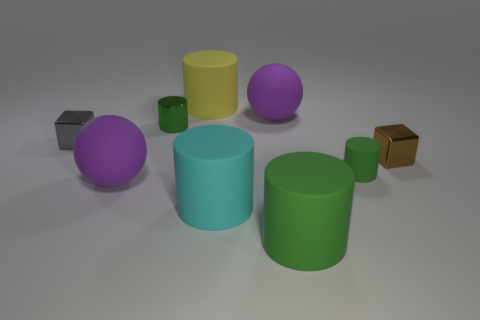There is a matte thing that is the same color as the tiny rubber cylinder; what size is it?
Offer a very short reply. Large. Is there any other thing that is the same shape as the big green matte object?
Provide a short and direct response. Yes. There is a small cylinder that is left of the large purple matte sphere that is behind the gray cube; are there any big purple spheres in front of it?
Keep it short and to the point. Yes. How many big yellow things are the same material as the brown cube?
Ensure brevity in your answer.  0. There is a green matte cylinder that is on the left side of the tiny green rubber cylinder; is its size the same as the shiny block on the right side of the large green matte thing?
Offer a terse response. No. There is a small metallic cube right of the big purple matte object that is in front of the tiny green thing that is behind the small green rubber cylinder; what color is it?
Make the answer very short. Brown. Is there a small green rubber thing that has the same shape as the big green matte object?
Give a very brief answer. Yes. Are there an equal number of metal blocks that are on the right side of the small gray metallic block and gray blocks on the right side of the small metallic cylinder?
Your answer should be very brief. No. There is a large purple matte object in front of the gray thing; is its shape the same as the small brown metal object?
Make the answer very short. No. Does the yellow thing have the same shape as the tiny green metal object?
Give a very brief answer. Yes. 